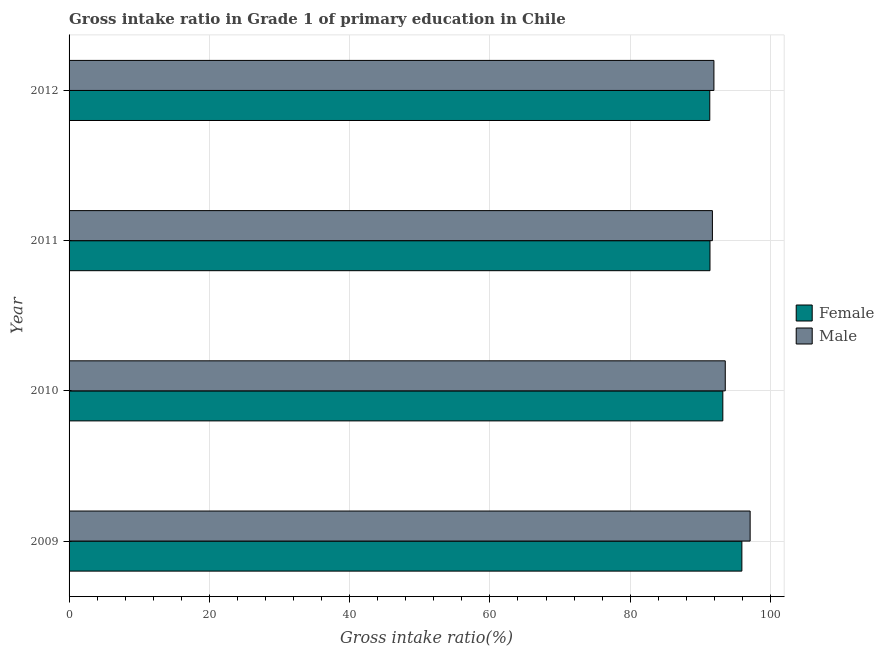How many different coloured bars are there?
Your answer should be compact. 2. Are the number of bars per tick equal to the number of legend labels?
Offer a terse response. Yes. How many bars are there on the 4th tick from the top?
Your answer should be very brief. 2. How many bars are there on the 2nd tick from the bottom?
Offer a terse response. 2. What is the label of the 1st group of bars from the top?
Keep it short and to the point. 2012. What is the gross intake ratio(female) in 2010?
Ensure brevity in your answer.  93.21. Across all years, what is the maximum gross intake ratio(male)?
Provide a short and direct response. 97.1. Across all years, what is the minimum gross intake ratio(female)?
Provide a short and direct response. 91.35. In which year was the gross intake ratio(female) maximum?
Provide a short and direct response. 2009. What is the total gross intake ratio(female) in the graph?
Give a very brief answer. 371.86. What is the difference between the gross intake ratio(female) in 2010 and that in 2011?
Give a very brief answer. 1.83. What is the difference between the gross intake ratio(male) in 2010 and the gross intake ratio(female) in 2011?
Your answer should be compact. 2.18. What is the average gross intake ratio(male) per year?
Your answer should be very brief. 93.58. In the year 2010, what is the difference between the gross intake ratio(male) and gross intake ratio(female)?
Your response must be concise. 0.35. Is the gross intake ratio(male) in 2010 less than that in 2011?
Ensure brevity in your answer.  No. Is the difference between the gross intake ratio(female) in 2009 and 2011 greater than the difference between the gross intake ratio(male) in 2009 and 2011?
Your answer should be compact. No. What is the difference between the highest and the second highest gross intake ratio(female)?
Keep it short and to the point. 2.71. What is the difference between the highest and the lowest gross intake ratio(female)?
Your answer should be very brief. 4.57. In how many years, is the gross intake ratio(male) greater than the average gross intake ratio(male) taken over all years?
Your answer should be very brief. 1. Is the sum of the gross intake ratio(male) in 2009 and 2011 greater than the maximum gross intake ratio(female) across all years?
Offer a very short reply. Yes. What does the 2nd bar from the top in 2009 represents?
Your response must be concise. Female. What does the 2nd bar from the bottom in 2010 represents?
Offer a terse response. Male. Are all the bars in the graph horizontal?
Offer a terse response. Yes. How many years are there in the graph?
Your answer should be very brief. 4. What is the difference between two consecutive major ticks on the X-axis?
Make the answer very short. 20. Does the graph contain any zero values?
Make the answer very short. No. Does the graph contain grids?
Provide a short and direct response. Yes. Where does the legend appear in the graph?
Offer a terse response. Center right. How many legend labels are there?
Offer a very short reply. 2. How are the legend labels stacked?
Offer a very short reply. Vertical. What is the title of the graph?
Make the answer very short. Gross intake ratio in Grade 1 of primary education in Chile. Does "Automatic Teller Machines" appear as one of the legend labels in the graph?
Offer a very short reply. No. What is the label or title of the X-axis?
Your answer should be compact. Gross intake ratio(%). What is the label or title of the Y-axis?
Keep it short and to the point. Year. What is the Gross intake ratio(%) in Female in 2009?
Provide a succinct answer. 95.92. What is the Gross intake ratio(%) in Male in 2009?
Your answer should be very brief. 97.1. What is the Gross intake ratio(%) of Female in 2010?
Ensure brevity in your answer.  93.21. What is the Gross intake ratio(%) in Male in 2010?
Ensure brevity in your answer.  93.56. What is the Gross intake ratio(%) in Female in 2011?
Give a very brief answer. 91.38. What is the Gross intake ratio(%) in Male in 2011?
Provide a succinct answer. 91.72. What is the Gross intake ratio(%) of Female in 2012?
Provide a short and direct response. 91.35. What is the Gross intake ratio(%) of Male in 2012?
Your response must be concise. 91.94. Across all years, what is the maximum Gross intake ratio(%) of Female?
Offer a very short reply. 95.92. Across all years, what is the maximum Gross intake ratio(%) of Male?
Provide a short and direct response. 97.1. Across all years, what is the minimum Gross intake ratio(%) in Female?
Your response must be concise. 91.35. Across all years, what is the minimum Gross intake ratio(%) in Male?
Your answer should be compact. 91.72. What is the total Gross intake ratio(%) in Female in the graph?
Ensure brevity in your answer.  371.86. What is the total Gross intake ratio(%) of Male in the graph?
Make the answer very short. 374.33. What is the difference between the Gross intake ratio(%) in Female in 2009 and that in 2010?
Your response must be concise. 2.71. What is the difference between the Gross intake ratio(%) of Male in 2009 and that in 2010?
Make the answer very short. 3.55. What is the difference between the Gross intake ratio(%) of Female in 2009 and that in 2011?
Your response must be concise. 4.55. What is the difference between the Gross intake ratio(%) of Male in 2009 and that in 2011?
Provide a short and direct response. 5.38. What is the difference between the Gross intake ratio(%) in Female in 2009 and that in 2012?
Your answer should be very brief. 4.57. What is the difference between the Gross intake ratio(%) of Male in 2009 and that in 2012?
Ensure brevity in your answer.  5.16. What is the difference between the Gross intake ratio(%) of Female in 2010 and that in 2011?
Make the answer very short. 1.83. What is the difference between the Gross intake ratio(%) of Male in 2010 and that in 2011?
Keep it short and to the point. 1.83. What is the difference between the Gross intake ratio(%) in Female in 2010 and that in 2012?
Provide a short and direct response. 1.86. What is the difference between the Gross intake ratio(%) of Male in 2010 and that in 2012?
Provide a short and direct response. 1.62. What is the difference between the Gross intake ratio(%) in Female in 2011 and that in 2012?
Your answer should be compact. 0.03. What is the difference between the Gross intake ratio(%) in Male in 2011 and that in 2012?
Your answer should be very brief. -0.22. What is the difference between the Gross intake ratio(%) in Female in 2009 and the Gross intake ratio(%) in Male in 2010?
Provide a succinct answer. 2.37. What is the difference between the Gross intake ratio(%) in Female in 2009 and the Gross intake ratio(%) in Male in 2011?
Your answer should be compact. 4.2. What is the difference between the Gross intake ratio(%) of Female in 2009 and the Gross intake ratio(%) of Male in 2012?
Your answer should be very brief. 3.98. What is the difference between the Gross intake ratio(%) of Female in 2010 and the Gross intake ratio(%) of Male in 2011?
Ensure brevity in your answer.  1.49. What is the difference between the Gross intake ratio(%) in Female in 2010 and the Gross intake ratio(%) in Male in 2012?
Provide a short and direct response. 1.27. What is the difference between the Gross intake ratio(%) of Female in 2011 and the Gross intake ratio(%) of Male in 2012?
Keep it short and to the point. -0.56. What is the average Gross intake ratio(%) in Female per year?
Provide a succinct answer. 92.97. What is the average Gross intake ratio(%) of Male per year?
Provide a short and direct response. 93.58. In the year 2009, what is the difference between the Gross intake ratio(%) in Female and Gross intake ratio(%) in Male?
Your answer should be very brief. -1.18. In the year 2010, what is the difference between the Gross intake ratio(%) of Female and Gross intake ratio(%) of Male?
Make the answer very short. -0.35. In the year 2011, what is the difference between the Gross intake ratio(%) of Female and Gross intake ratio(%) of Male?
Offer a terse response. -0.35. In the year 2012, what is the difference between the Gross intake ratio(%) of Female and Gross intake ratio(%) of Male?
Provide a short and direct response. -0.59. What is the ratio of the Gross intake ratio(%) in Female in 2009 to that in 2010?
Provide a short and direct response. 1.03. What is the ratio of the Gross intake ratio(%) of Male in 2009 to that in 2010?
Make the answer very short. 1.04. What is the ratio of the Gross intake ratio(%) in Female in 2009 to that in 2011?
Keep it short and to the point. 1.05. What is the ratio of the Gross intake ratio(%) of Male in 2009 to that in 2011?
Keep it short and to the point. 1.06. What is the ratio of the Gross intake ratio(%) in Female in 2009 to that in 2012?
Provide a succinct answer. 1.05. What is the ratio of the Gross intake ratio(%) in Male in 2009 to that in 2012?
Give a very brief answer. 1.06. What is the ratio of the Gross intake ratio(%) of Male in 2010 to that in 2011?
Provide a succinct answer. 1.02. What is the ratio of the Gross intake ratio(%) of Female in 2010 to that in 2012?
Make the answer very short. 1.02. What is the ratio of the Gross intake ratio(%) of Male in 2010 to that in 2012?
Your answer should be very brief. 1.02. What is the ratio of the Gross intake ratio(%) of Female in 2011 to that in 2012?
Ensure brevity in your answer.  1. What is the ratio of the Gross intake ratio(%) in Male in 2011 to that in 2012?
Your answer should be compact. 1. What is the difference between the highest and the second highest Gross intake ratio(%) in Female?
Your answer should be compact. 2.71. What is the difference between the highest and the second highest Gross intake ratio(%) in Male?
Your answer should be very brief. 3.55. What is the difference between the highest and the lowest Gross intake ratio(%) in Female?
Make the answer very short. 4.57. What is the difference between the highest and the lowest Gross intake ratio(%) of Male?
Ensure brevity in your answer.  5.38. 